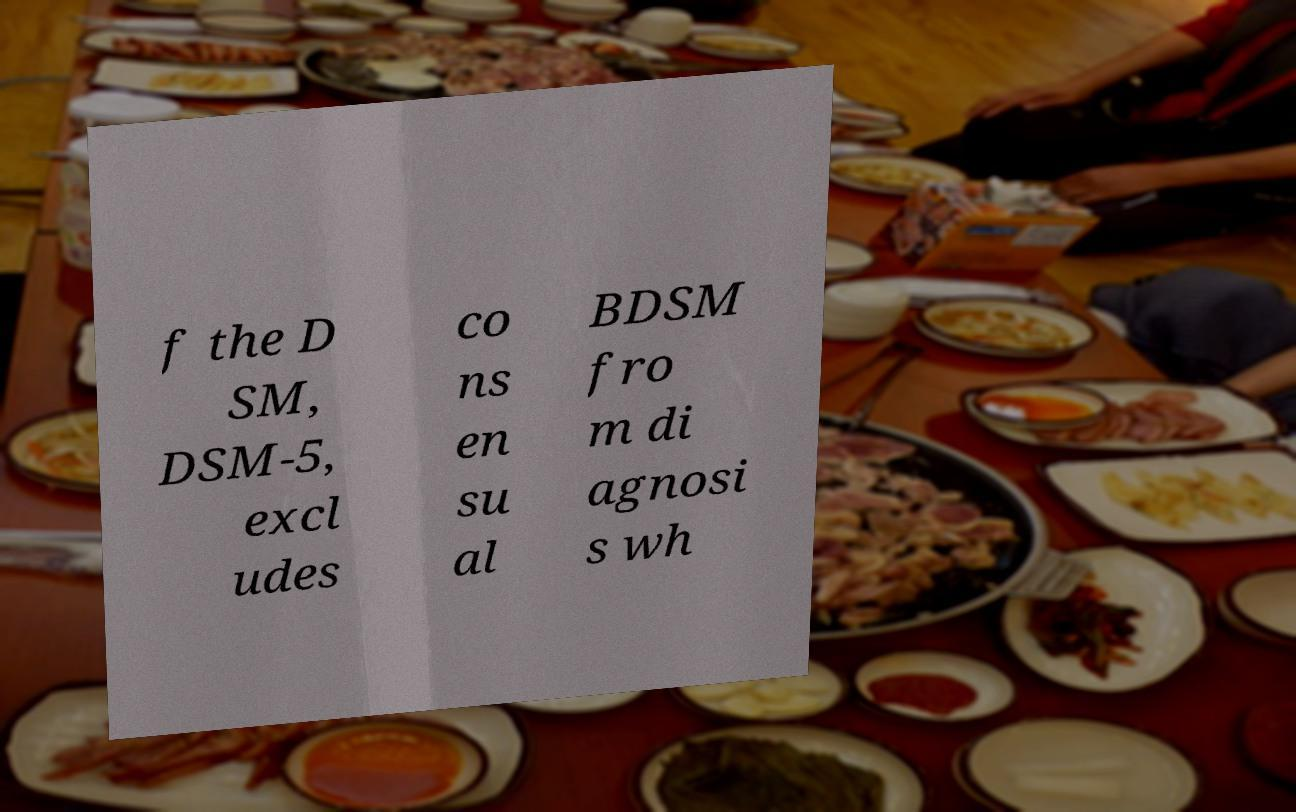For documentation purposes, I need the text within this image transcribed. Could you provide that? f the D SM, DSM-5, excl udes co ns en su al BDSM fro m di agnosi s wh 